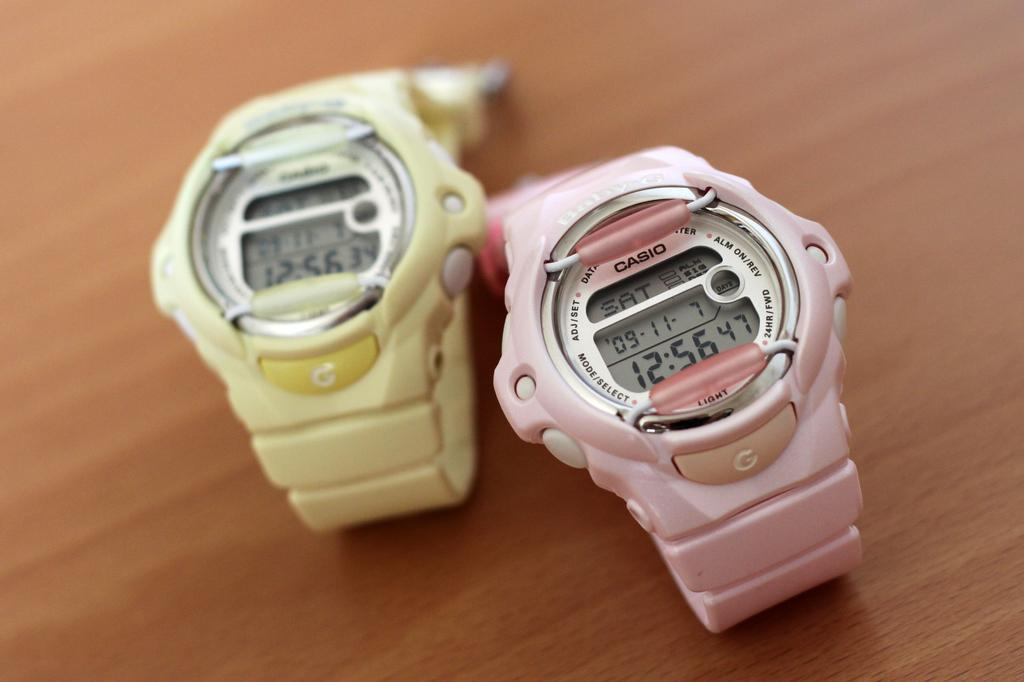Provide a one-sentence caption for the provided image. A pink watch with the word CASIO printed on it. 